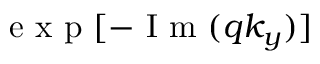Convert formula to latex. <formula><loc_0><loc_0><loc_500><loc_500>e x p [ - I m ( q k _ { y } ) ]</formula> 